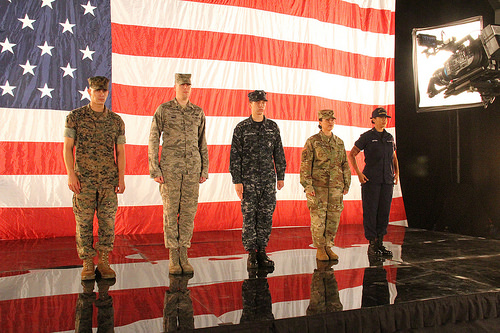<image>
Is there a flag on the soldier? No. The flag is not positioned on the soldier. They may be near each other, but the flag is not supported by or resting on top of the soldier. Is there a camera next to the man? No. The camera is not positioned next to the man. They are located in different areas of the scene. Is there a camera above the stage? Yes. The camera is positioned above the stage in the vertical space, higher up in the scene. 